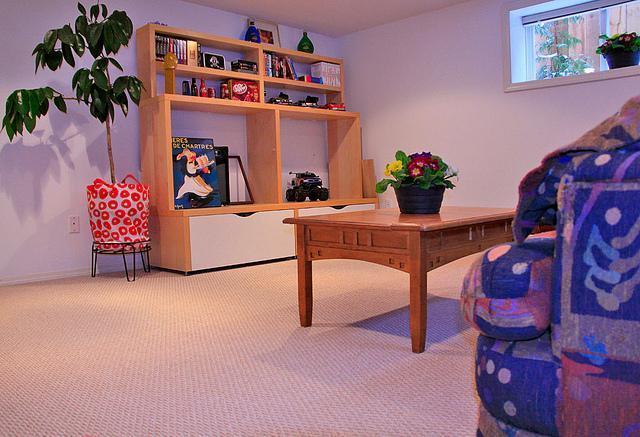How many potted plants are in the photo?
Give a very brief answer. 2. 